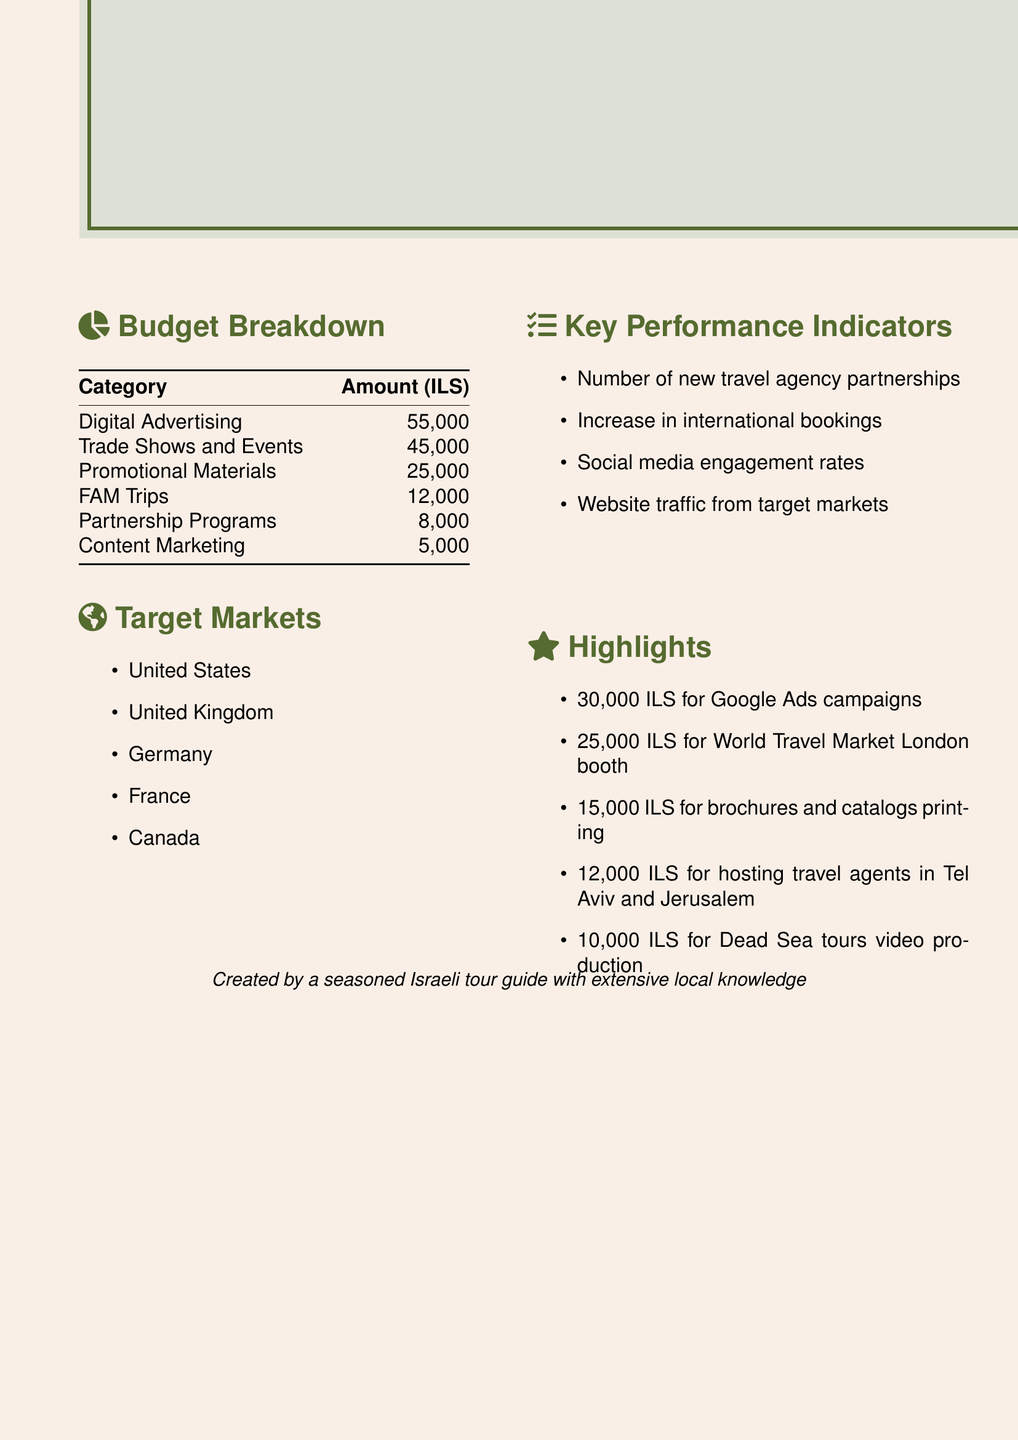What is the total budget? The total budget is stated at the beginning of the document as the complete amount allocated for the quarter.
Answer: 150,000 ILS How much is allocated for digital advertising? The budget breakdown section lists the amount specifically designated for digital advertising as part of the overall budget.
Answer: 55,000 Which category has the lowest budget allocation? In the budget breakdown, we can see that the category with the smallest allocation is mentioned.
Answer: Content Marketing What are the target markets listed? The target markets are outlined in a bullet list within the document, specifying the countries targeted for outreach.
Answer: United States, United Kingdom, Germany, France, Canada How much is budgeted for FAM trips? The amount assigned to FAM Trips is detailed under the budget breakdown section of the document.
Answer: 12,000 What is one key performance indicator mentioned? The key performance indicators are listed in bullet points, and any one of them can be referred to as an example.
Answer: Number of new travel agency partnerships What is a highlight of the marketing budget? Highlights are specified in a list format, showcasing notable expenses within the budget.
Answer: 30,000 ILS for Google Ads campaigns How much is allocated for promotional materials? The specific amount set for promotional materials is included in the budget breakdown section.
Answer: 25,000 Which event has a budget allocation of 25,000 ILS? The highlights section mentions an event related to international travel that has a specific budget tied to it.
Answer: World Travel Market London booth 